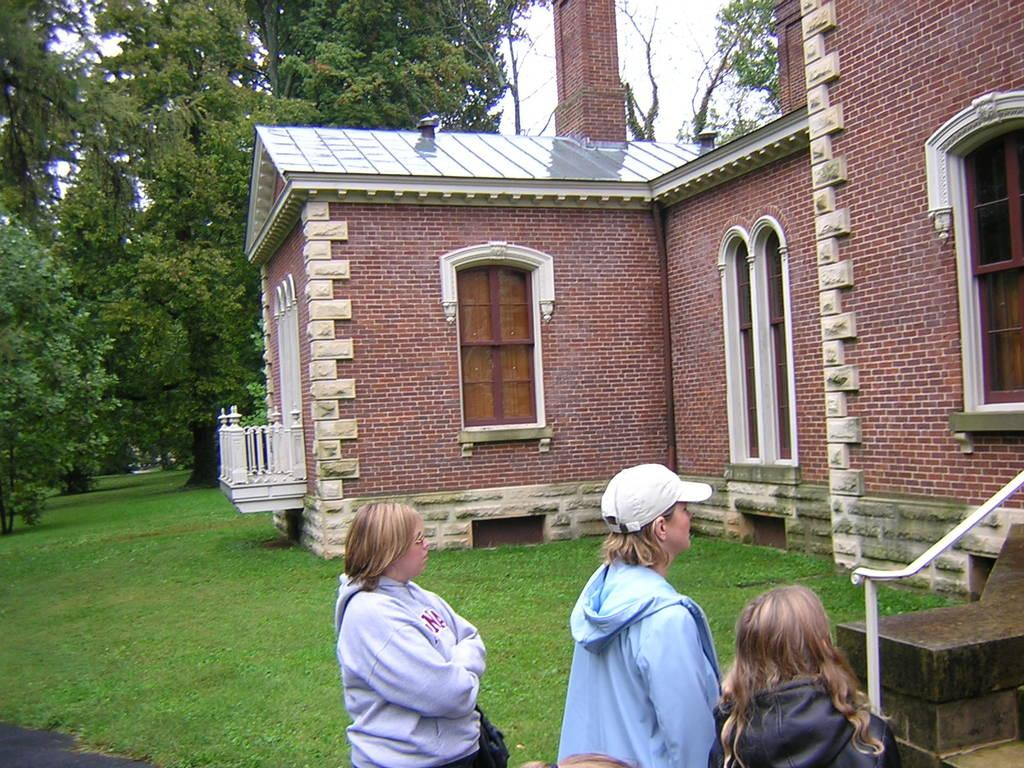Where is the picture taken? The picture is taken near a house. How many people are in the foreground of the image? There are three people in the foreground of the image. What is the main structure in the center of the picture? The house is in the center of the picture. What features can be seen on the house? The house has windows, a door, and railings. What type of vegetation is present in the image? Grass is present in the image, and trees are visible as well. What type of pie is being served to the governor in the image? There is no governor or pie present in the image. How many chickens are visible in the image? There are no chickens visible in the image. 